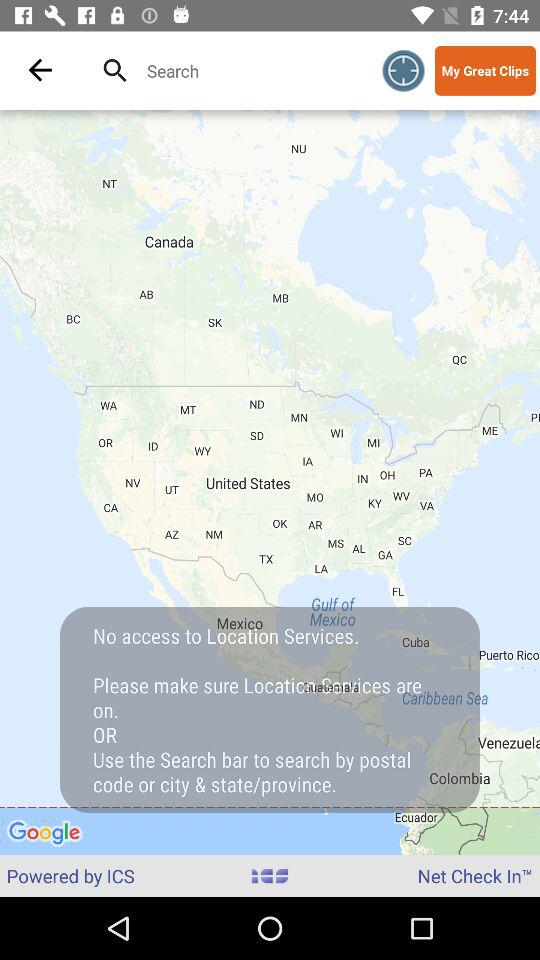By whom is it powered? It is powered by ICS. 